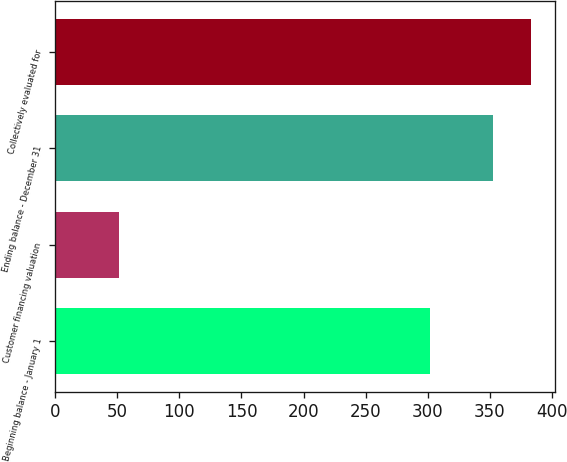Convert chart. <chart><loc_0><loc_0><loc_500><loc_500><bar_chart><fcel>Beginning balance - January 1<fcel>Customer financing valuation<fcel>Ending balance - December 31<fcel>Collectively evaluated for<nl><fcel>302<fcel>51<fcel>353<fcel>383.2<nl></chart> 